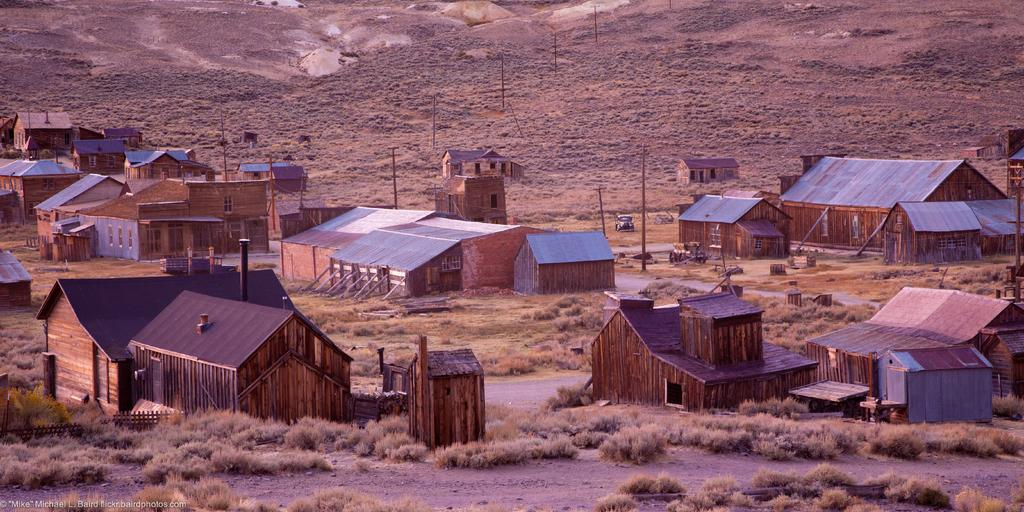What type of structures can be seen in the image? There are houses in the image. What feature is common to many of the houses in the image? There are windows in the image. What are the poles used for in the image? The purpose of the poles in the image is not specified, but they could be for various purposes such as supporting wires or signs. What mode of transportation is present in the image? There is a vehicle in the image. What type of vegetation can be seen in the image? There is dry grass in the image. What type of barrier is present in the image? There is fencing in the image. What type of natural feature can be seen in the image? There are rocks in the image. What type of cream can be seen on top of the rocks in the image? There is no cream present on top of the rocks in the image. What is the need for the rocks in the image? The purpose or need for the rocks in the image is not specified, as they could be for various purposes such as landscaping or erosion control. 